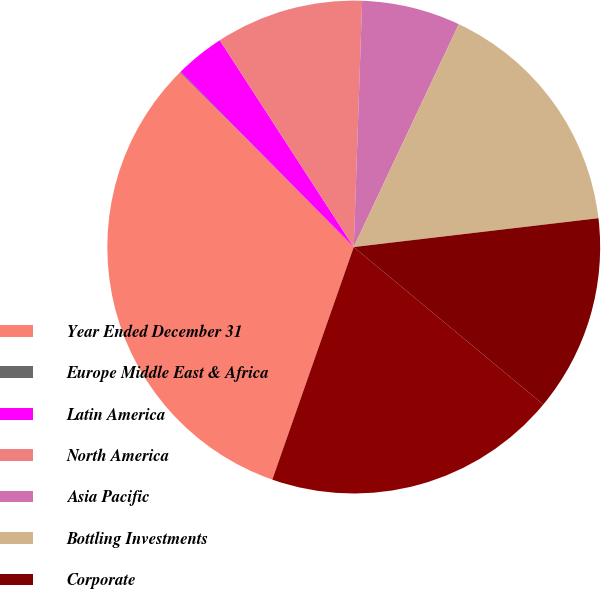<chart> <loc_0><loc_0><loc_500><loc_500><pie_chart><fcel>Year Ended December 31<fcel>Europe Middle East & Africa<fcel>Latin America<fcel>North America<fcel>Asia Pacific<fcel>Bottling Investments<fcel>Corporate<fcel>Total<nl><fcel>32.18%<fcel>0.05%<fcel>3.26%<fcel>9.69%<fcel>6.47%<fcel>16.12%<fcel>12.9%<fcel>19.33%<nl></chart> 